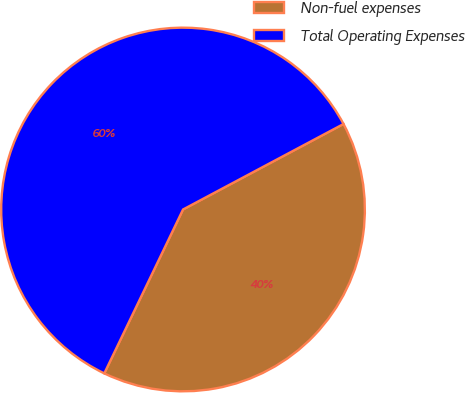<chart> <loc_0><loc_0><loc_500><loc_500><pie_chart><fcel>Non-fuel expenses<fcel>Total Operating Expenses<nl><fcel>39.92%<fcel>60.08%<nl></chart> 